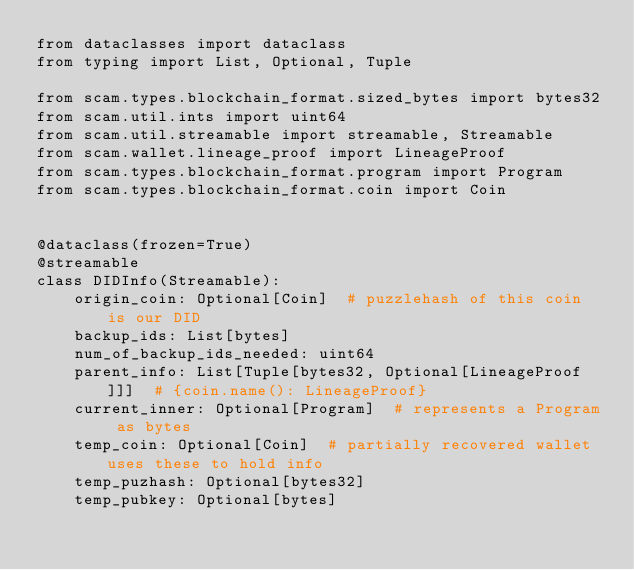Convert code to text. <code><loc_0><loc_0><loc_500><loc_500><_Python_>from dataclasses import dataclass
from typing import List, Optional, Tuple

from scam.types.blockchain_format.sized_bytes import bytes32
from scam.util.ints import uint64
from scam.util.streamable import streamable, Streamable
from scam.wallet.lineage_proof import LineageProof
from scam.types.blockchain_format.program import Program
from scam.types.blockchain_format.coin import Coin


@dataclass(frozen=True)
@streamable
class DIDInfo(Streamable):
    origin_coin: Optional[Coin]  # puzzlehash of this coin is our DID
    backup_ids: List[bytes]
    num_of_backup_ids_needed: uint64
    parent_info: List[Tuple[bytes32, Optional[LineageProof]]]  # {coin.name(): LineageProof}
    current_inner: Optional[Program]  # represents a Program as bytes
    temp_coin: Optional[Coin]  # partially recovered wallet uses these to hold info
    temp_puzhash: Optional[bytes32]
    temp_pubkey: Optional[bytes]
</code> 